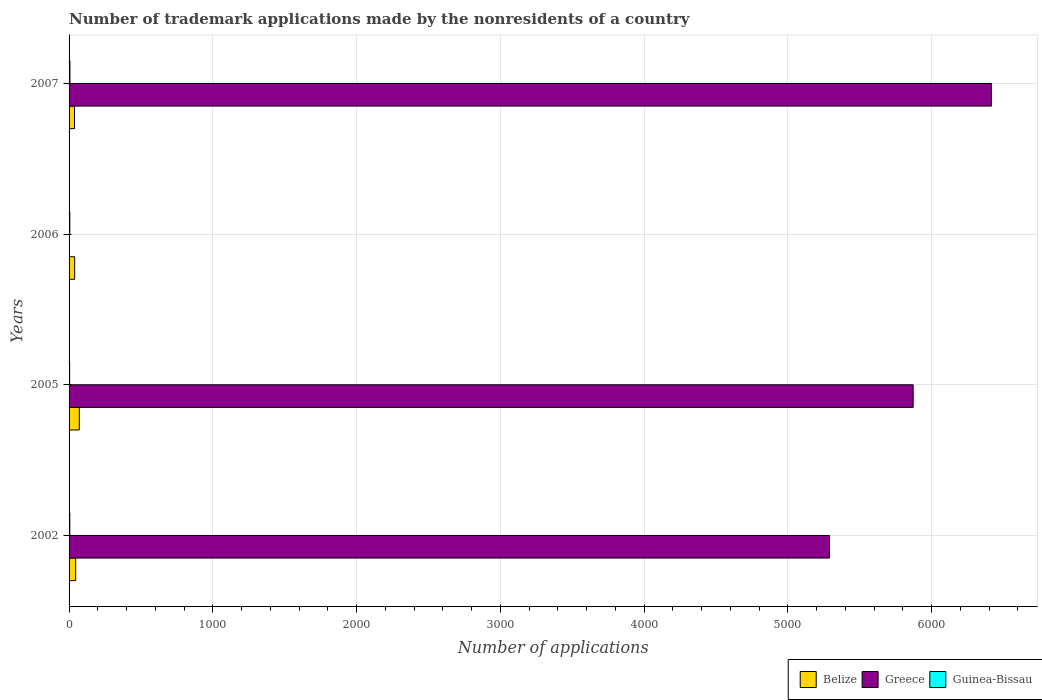How many different coloured bars are there?
Your response must be concise. 3. How many groups of bars are there?
Provide a short and direct response. 4. What is the label of the 1st group of bars from the top?
Offer a very short reply. 2007. What is the number of trademark applications made by the nonresidents in Greece in 2006?
Provide a succinct answer. 2. Across all years, what is the minimum number of trademark applications made by the nonresidents in Greece?
Your response must be concise. 2. In which year was the number of trademark applications made by the nonresidents in Guinea-Bissau maximum?
Your answer should be compact. 2007. In which year was the number of trademark applications made by the nonresidents in Greece minimum?
Your response must be concise. 2006. What is the total number of trademark applications made by the nonresidents in Belize in the graph?
Ensure brevity in your answer.  194. What is the difference between the number of trademark applications made by the nonresidents in Guinea-Bissau in 2006 and that in 2007?
Keep it short and to the point. -1. What is the difference between the number of trademark applications made by the nonresidents in Belize in 2007 and the number of trademark applications made by the nonresidents in Greece in 2002?
Your answer should be very brief. -5252. What is the average number of trademark applications made by the nonresidents in Belize per year?
Provide a succinct answer. 48.5. In the year 2006, what is the difference between the number of trademark applications made by the nonresidents in Guinea-Bissau and number of trademark applications made by the nonresidents in Belize?
Make the answer very short. -34. What is the ratio of the number of trademark applications made by the nonresidents in Greece in 2005 to that in 2007?
Your response must be concise. 0.92. What is the difference between the highest and the second highest number of trademark applications made by the nonresidents in Belize?
Provide a succinct answer. 25. What is the difference between the highest and the lowest number of trademark applications made by the nonresidents in Guinea-Bissau?
Ensure brevity in your answer.  2. In how many years, is the number of trademark applications made by the nonresidents in Belize greater than the average number of trademark applications made by the nonresidents in Belize taken over all years?
Offer a terse response. 1. What does the 3rd bar from the bottom in 2006 represents?
Provide a succinct answer. Guinea-Bissau. Is it the case that in every year, the sum of the number of trademark applications made by the nonresidents in Belize and number of trademark applications made by the nonresidents in Guinea-Bissau is greater than the number of trademark applications made by the nonresidents in Greece?
Ensure brevity in your answer.  No. How many bars are there?
Make the answer very short. 12. How many years are there in the graph?
Ensure brevity in your answer.  4. Are the values on the major ticks of X-axis written in scientific E-notation?
Give a very brief answer. No. Does the graph contain any zero values?
Provide a succinct answer. No. How many legend labels are there?
Provide a short and direct response. 3. How are the legend labels stacked?
Your answer should be very brief. Horizontal. What is the title of the graph?
Ensure brevity in your answer.  Number of trademark applications made by the nonresidents of a country. Does "Latin America(developing only)" appear as one of the legend labels in the graph?
Your response must be concise. No. What is the label or title of the X-axis?
Provide a succinct answer. Number of applications. What is the Number of applications in Belize in 2002?
Make the answer very short. 46. What is the Number of applications of Greece in 2002?
Provide a succinct answer. 5290. What is the Number of applications of Belize in 2005?
Offer a very short reply. 71. What is the Number of applications of Greece in 2005?
Keep it short and to the point. 5872. What is the Number of applications of Guinea-Bissau in 2005?
Your answer should be very brief. 4. What is the Number of applications in Guinea-Bissau in 2006?
Your answer should be compact. 5. What is the Number of applications of Greece in 2007?
Keep it short and to the point. 6416. What is the Number of applications of Guinea-Bissau in 2007?
Make the answer very short. 6. Across all years, what is the maximum Number of applications of Greece?
Make the answer very short. 6416. Across all years, what is the maximum Number of applications of Guinea-Bissau?
Your answer should be compact. 6. Across all years, what is the minimum Number of applications of Greece?
Make the answer very short. 2. Across all years, what is the minimum Number of applications of Guinea-Bissau?
Provide a succinct answer. 4. What is the total Number of applications in Belize in the graph?
Offer a very short reply. 194. What is the total Number of applications in Greece in the graph?
Offer a very short reply. 1.76e+04. What is the total Number of applications in Guinea-Bissau in the graph?
Your answer should be compact. 20. What is the difference between the Number of applications of Belize in 2002 and that in 2005?
Make the answer very short. -25. What is the difference between the Number of applications in Greece in 2002 and that in 2005?
Provide a succinct answer. -582. What is the difference between the Number of applications of Belize in 2002 and that in 2006?
Your response must be concise. 7. What is the difference between the Number of applications of Greece in 2002 and that in 2006?
Offer a terse response. 5288. What is the difference between the Number of applications in Greece in 2002 and that in 2007?
Provide a short and direct response. -1126. What is the difference between the Number of applications of Guinea-Bissau in 2002 and that in 2007?
Your response must be concise. -1. What is the difference between the Number of applications in Belize in 2005 and that in 2006?
Give a very brief answer. 32. What is the difference between the Number of applications in Greece in 2005 and that in 2006?
Your response must be concise. 5870. What is the difference between the Number of applications in Belize in 2005 and that in 2007?
Give a very brief answer. 33. What is the difference between the Number of applications of Greece in 2005 and that in 2007?
Provide a short and direct response. -544. What is the difference between the Number of applications in Greece in 2006 and that in 2007?
Offer a terse response. -6414. What is the difference between the Number of applications of Belize in 2002 and the Number of applications of Greece in 2005?
Offer a very short reply. -5826. What is the difference between the Number of applications in Greece in 2002 and the Number of applications in Guinea-Bissau in 2005?
Your answer should be very brief. 5286. What is the difference between the Number of applications in Belize in 2002 and the Number of applications in Greece in 2006?
Provide a succinct answer. 44. What is the difference between the Number of applications in Greece in 2002 and the Number of applications in Guinea-Bissau in 2006?
Provide a short and direct response. 5285. What is the difference between the Number of applications of Belize in 2002 and the Number of applications of Greece in 2007?
Make the answer very short. -6370. What is the difference between the Number of applications in Greece in 2002 and the Number of applications in Guinea-Bissau in 2007?
Give a very brief answer. 5284. What is the difference between the Number of applications in Belize in 2005 and the Number of applications in Greece in 2006?
Offer a very short reply. 69. What is the difference between the Number of applications of Greece in 2005 and the Number of applications of Guinea-Bissau in 2006?
Provide a short and direct response. 5867. What is the difference between the Number of applications of Belize in 2005 and the Number of applications of Greece in 2007?
Ensure brevity in your answer.  -6345. What is the difference between the Number of applications of Belize in 2005 and the Number of applications of Guinea-Bissau in 2007?
Give a very brief answer. 65. What is the difference between the Number of applications in Greece in 2005 and the Number of applications in Guinea-Bissau in 2007?
Keep it short and to the point. 5866. What is the difference between the Number of applications in Belize in 2006 and the Number of applications in Greece in 2007?
Give a very brief answer. -6377. What is the difference between the Number of applications in Belize in 2006 and the Number of applications in Guinea-Bissau in 2007?
Keep it short and to the point. 33. What is the difference between the Number of applications in Greece in 2006 and the Number of applications in Guinea-Bissau in 2007?
Your answer should be compact. -4. What is the average Number of applications of Belize per year?
Provide a succinct answer. 48.5. What is the average Number of applications in Greece per year?
Your answer should be very brief. 4395. What is the average Number of applications of Guinea-Bissau per year?
Keep it short and to the point. 5. In the year 2002, what is the difference between the Number of applications in Belize and Number of applications in Greece?
Keep it short and to the point. -5244. In the year 2002, what is the difference between the Number of applications in Greece and Number of applications in Guinea-Bissau?
Provide a short and direct response. 5285. In the year 2005, what is the difference between the Number of applications of Belize and Number of applications of Greece?
Offer a very short reply. -5801. In the year 2005, what is the difference between the Number of applications in Belize and Number of applications in Guinea-Bissau?
Your response must be concise. 67. In the year 2005, what is the difference between the Number of applications in Greece and Number of applications in Guinea-Bissau?
Give a very brief answer. 5868. In the year 2006, what is the difference between the Number of applications of Greece and Number of applications of Guinea-Bissau?
Make the answer very short. -3. In the year 2007, what is the difference between the Number of applications of Belize and Number of applications of Greece?
Offer a very short reply. -6378. In the year 2007, what is the difference between the Number of applications in Greece and Number of applications in Guinea-Bissau?
Your response must be concise. 6410. What is the ratio of the Number of applications of Belize in 2002 to that in 2005?
Make the answer very short. 0.65. What is the ratio of the Number of applications in Greece in 2002 to that in 2005?
Give a very brief answer. 0.9. What is the ratio of the Number of applications in Guinea-Bissau in 2002 to that in 2005?
Provide a succinct answer. 1.25. What is the ratio of the Number of applications in Belize in 2002 to that in 2006?
Offer a very short reply. 1.18. What is the ratio of the Number of applications of Greece in 2002 to that in 2006?
Ensure brevity in your answer.  2645. What is the ratio of the Number of applications in Guinea-Bissau in 2002 to that in 2006?
Offer a very short reply. 1. What is the ratio of the Number of applications of Belize in 2002 to that in 2007?
Offer a terse response. 1.21. What is the ratio of the Number of applications of Greece in 2002 to that in 2007?
Your response must be concise. 0.82. What is the ratio of the Number of applications in Guinea-Bissau in 2002 to that in 2007?
Your response must be concise. 0.83. What is the ratio of the Number of applications in Belize in 2005 to that in 2006?
Give a very brief answer. 1.82. What is the ratio of the Number of applications in Greece in 2005 to that in 2006?
Give a very brief answer. 2936. What is the ratio of the Number of applications in Guinea-Bissau in 2005 to that in 2006?
Ensure brevity in your answer.  0.8. What is the ratio of the Number of applications of Belize in 2005 to that in 2007?
Ensure brevity in your answer.  1.87. What is the ratio of the Number of applications in Greece in 2005 to that in 2007?
Ensure brevity in your answer.  0.92. What is the ratio of the Number of applications of Guinea-Bissau in 2005 to that in 2007?
Ensure brevity in your answer.  0.67. What is the ratio of the Number of applications of Belize in 2006 to that in 2007?
Provide a succinct answer. 1.03. What is the ratio of the Number of applications of Greece in 2006 to that in 2007?
Your answer should be compact. 0. What is the ratio of the Number of applications in Guinea-Bissau in 2006 to that in 2007?
Offer a terse response. 0.83. What is the difference between the highest and the second highest Number of applications in Greece?
Offer a terse response. 544. What is the difference between the highest and the second highest Number of applications of Guinea-Bissau?
Make the answer very short. 1. What is the difference between the highest and the lowest Number of applications in Belize?
Provide a succinct answer. 33. What is the difference between the highest and the lowest Number of applications in Greece?
Provide a succinct answer. 6414. 